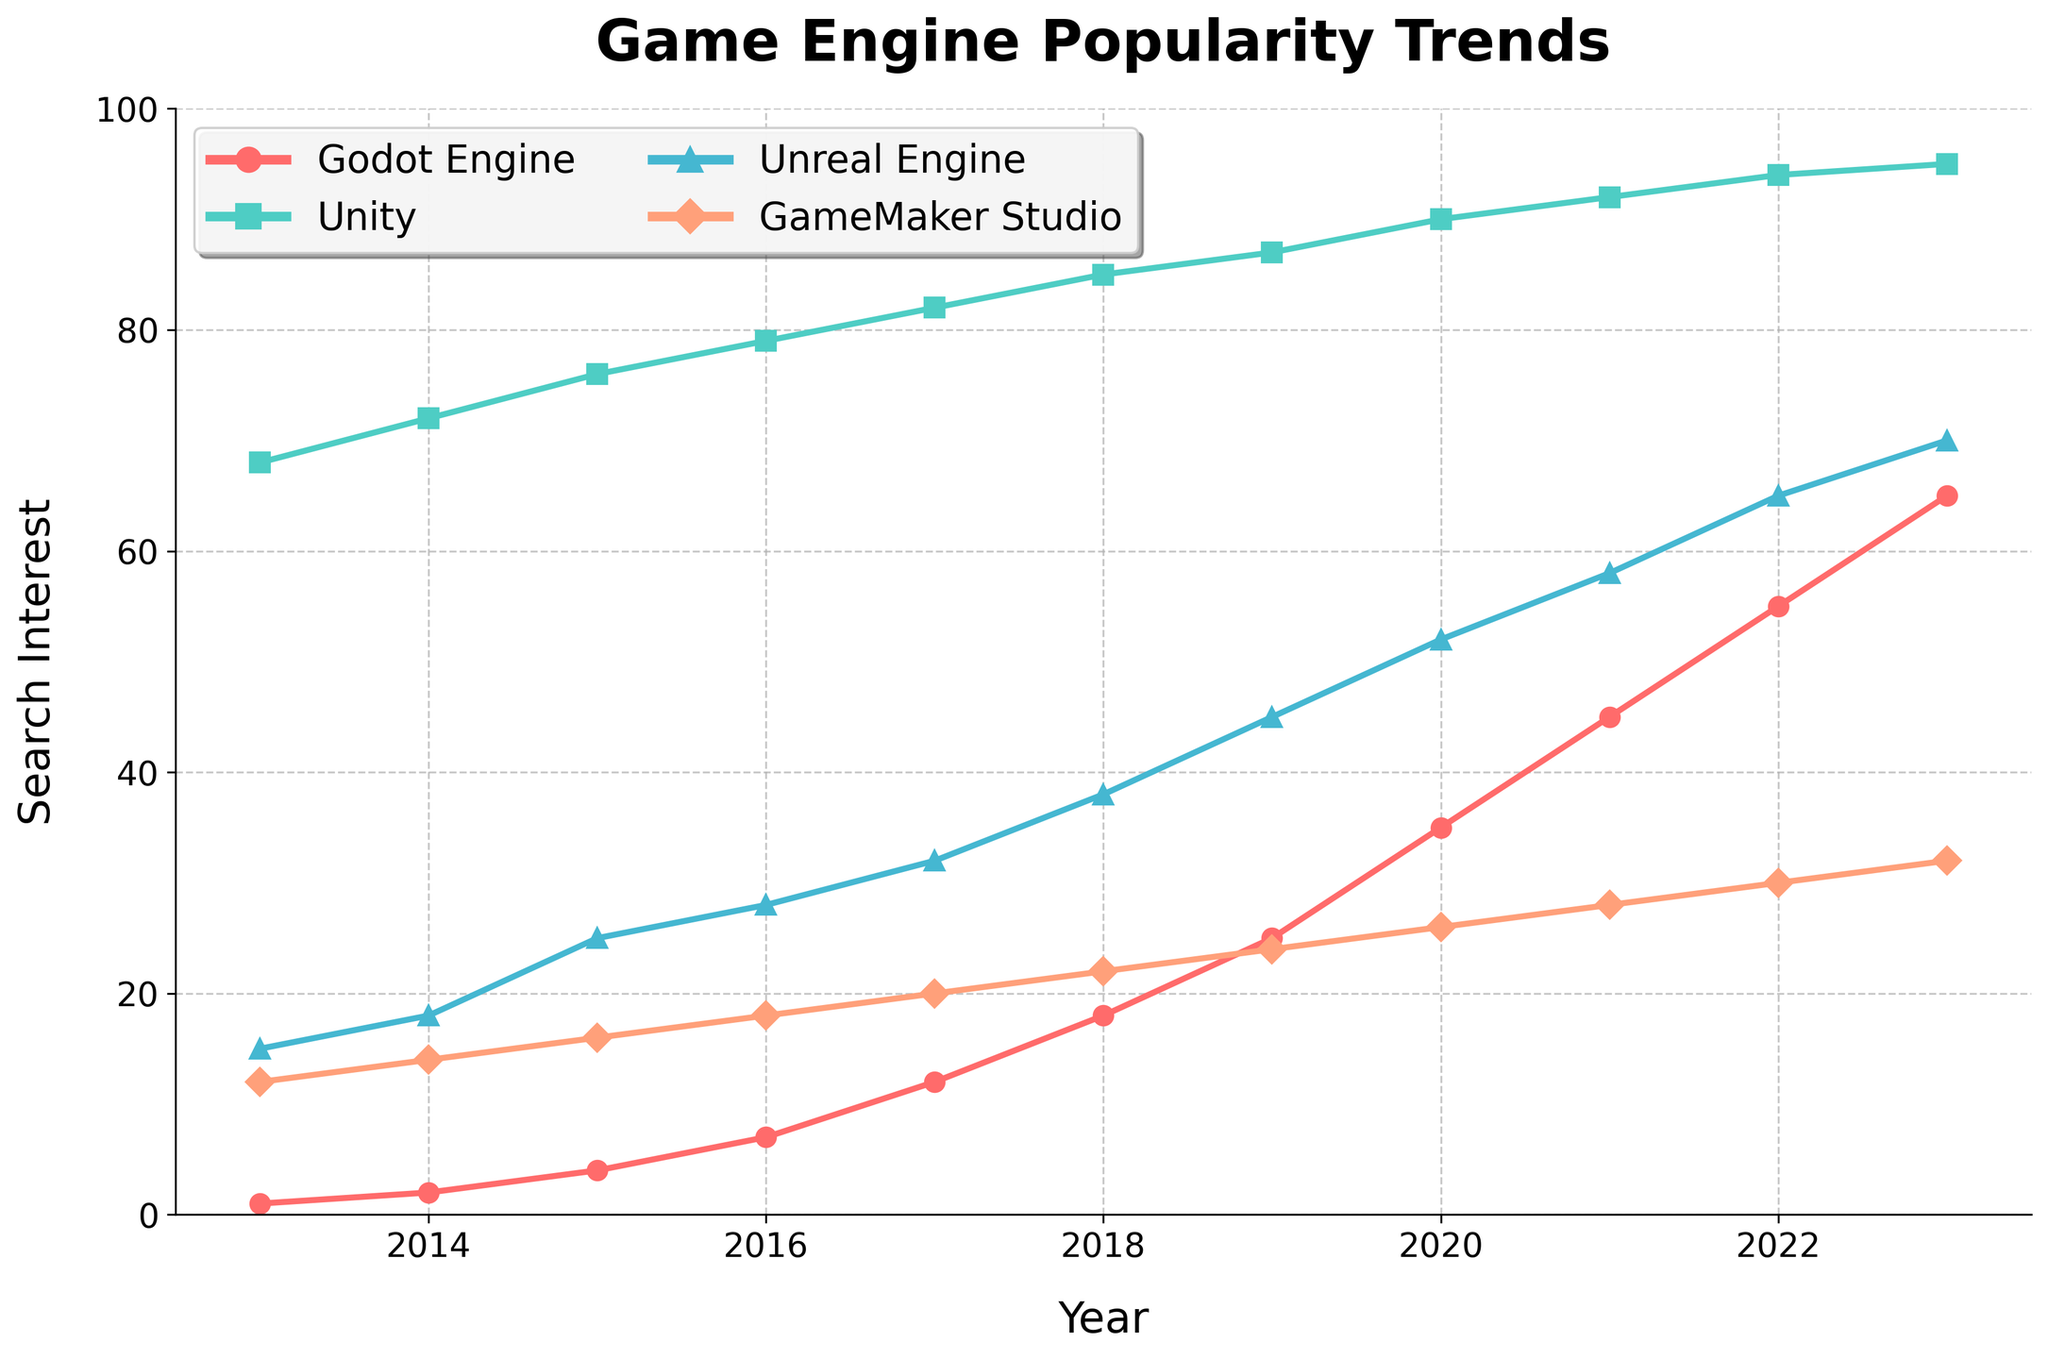What's the trend of the search interest for "Godot Engine" over the last decade? The search interest for "Godot Engine" has increased over the last decade. Starting from a value of 1 in 2013, it has steadily increased to 65 in 2023.
Answer: steadily increasing Which game engine had the highest search interest each year? By observing the highest points each year on the graph, it can be seen that "Unity" consistently had the highest search interest from 2013 to 2023.
Answer: Unity Which years had significant increases in search interest for "Godot Engine"? The years with noticeable increases in search interest for "Godot Engine" are 2017 (from 7 to 12), 2020 (from 25 to 35), and 2021 (from 35 to 45).
Answer: 2017, 2020, 2021 What is the difference in search interest between "Godot Engine" and "Unreal Engine" in 2023? In 2023, the search interest for "Godot Engine" is 65 and for "Unreal Engine" it is 70. The difference is 70 - 65 = 5.
Answer: 5 Which game engine had the smallest range of search interest over the last decade? To find the smallest range, find the difference between the maximum and minimum search interest values for each game engine. "Unity" has the smallest range: 95 - 68 = 27.
Answer: Unity In which year did "Godot Engine" surpass "GameMaker Studio" in search interest? Observing the intersection point on the graph, "Godot Engine" surpassed "GameMaker Studio" in 2020, where Godot Engine's interest was 35 compared to GameMaker Studio's 26.
Answer: 2020 What is the average search interest for "Unreal Engine" from 2013 to 2023? Sum of search interests for "Unreal Engine" from 2013 to 2023 is (15+18+25+28+32+38+45+52+58+65+70) = 446. The average is 446 / 11 ≈ 40.55.
Answer: 40.55 Which years did "Unity" see a small increase or decrease in search interest? Unity's search interest saw relatively small increases (less than or equal to 3) from 2013 to 2016: 68 to 72 (4), 72 to 76 (4), 76 to 79 (3), and 79 to 82 (3).
Answer: 2013-2016 Compare the search interest trends for "Godot Engine" and "GameMaker Studio" from 2013 to 2023. "Godot Engine" shows a strong upward trend from 1 to 65 over the years. In contrast, "GameMaker Studio" increases steadily but more modestly from 12 to 32.
Answer: Godot Engine has a stronger upward trend 